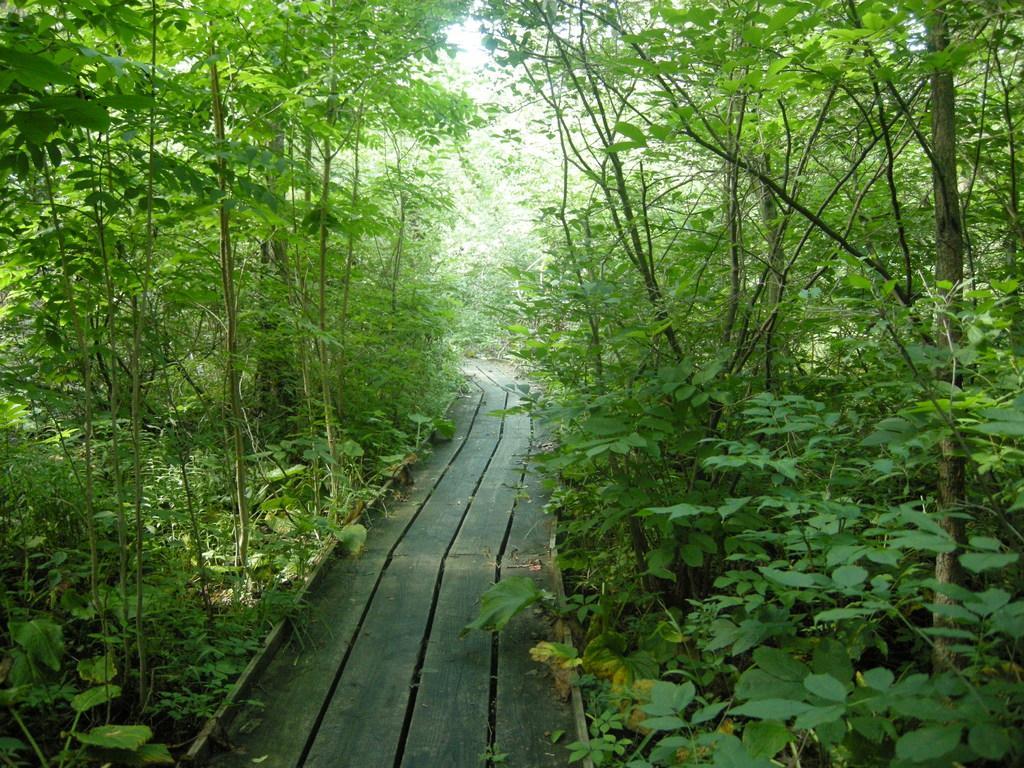Can you describe this image briefly? In this image there are plants, trees and wooden walkway. 